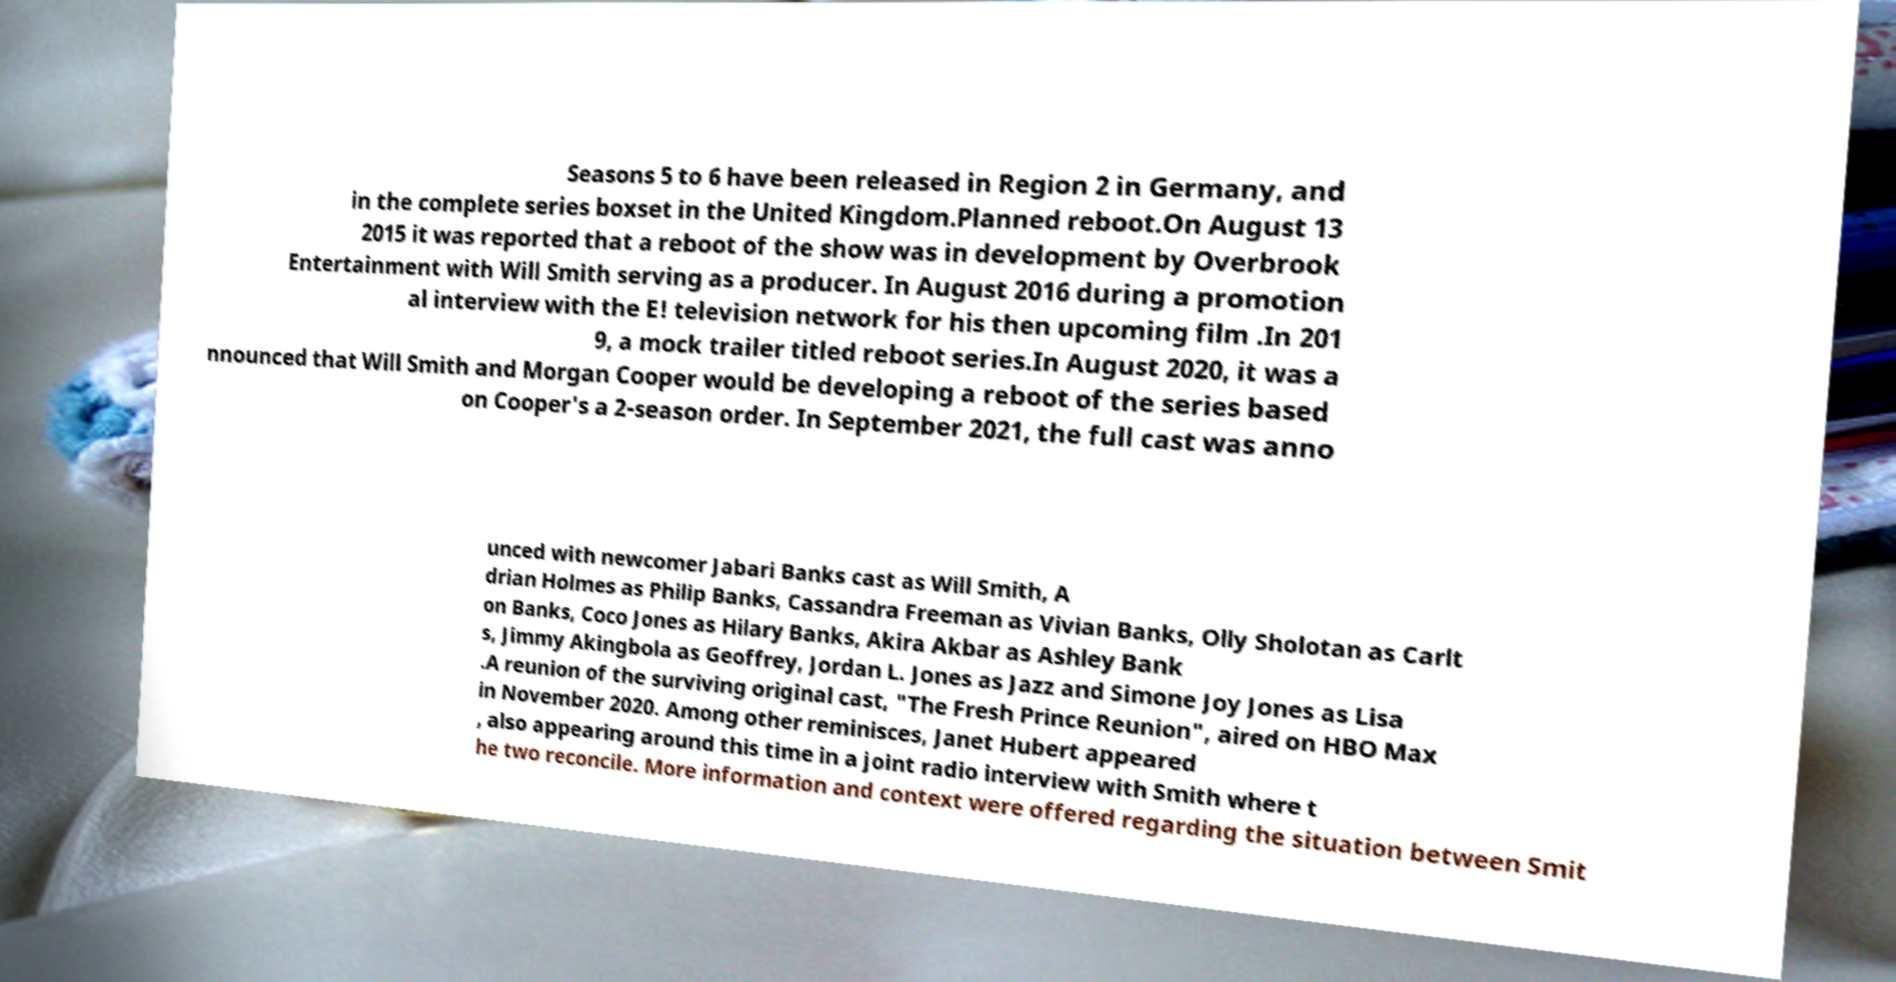Please identify and transcribe the text found in this image. Seasons 5 to 6 have been released in Region 2 in Germany, and in the complete series boxset in the United Kingdom.Planned reboot.On August 13 2015 it was reported that a reboot of the show was in development by Overbrook Entertainment with Will Smith serving as a producer. In August 2016 during a promotion al interview with the E! television network for his then upcoming film .In 201 9, a mock trailer titled reboot series.In August 2020, it was a nnounced that Will Smith and Morgan Cooper would be developing a reboot of the series based on Cooper's a 2-season order. In September 2021, the full cast was anno unced with newcomer Jabari Banks cast as Will Smith, A drian Holmes as Philip Banks, Cassandra Freeman as Vivian Banks, Olly Sholotan as Carlt on Banks, Coco Jones as Hilary Banks, Akira Akbar as Ashley Bank s, Jimmy Akingbola as Geoffrey, Jordan L. Jones as Jazz and Simone Joy Jones as Lisa .A reunion of the surviving original cast, "The Fresh Prince Reunion", aired on HBO Max in November 2020. Among other reminisces, Janet Hubert appeared , also appearing around this time in a joint radio interview with Smith where t he two reconcile. More information and context were offered regarding the situation between Smit 